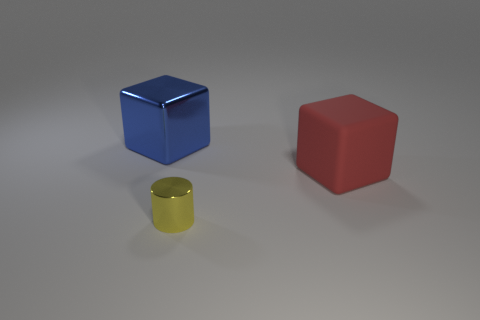Is there anything else that has the same size as the yellow metallic object?
Your answer should be very brief. No. What size is the blue shiny object?
Make the answer very short. Large. How many things are big red matte objects or large things that are left of the tiny yellow thing?
Offer a very short reply. 2. What number of other things are the same color as the large shiny block?
Offer a terse response. 0. Does the yellow metallic thing have the same size as the thing that is to the left of the small thing?
Offer a terse response. No. There is a object behind the red block; is its size the same as the rubber object?
Provide a short and direct response. Yes. What number of other things are made of the same material as the cylinder?
Ensure brevity in your answer.  1. Is the number of big blue metal blocks that are in front of the big blue object the same as the number of yellow objects that are to the left of the small yellow shiny thing?
Offer a very short reply. Yes. What is the color of the metallic thing that is right of the object behind the big block that is in front of the large blue thing?
Keep it short and to the point. Yellow. What is the shape of the metallic object that is in front of the large blue metallic thing?
Your answer should be very brief. Cylinder. 